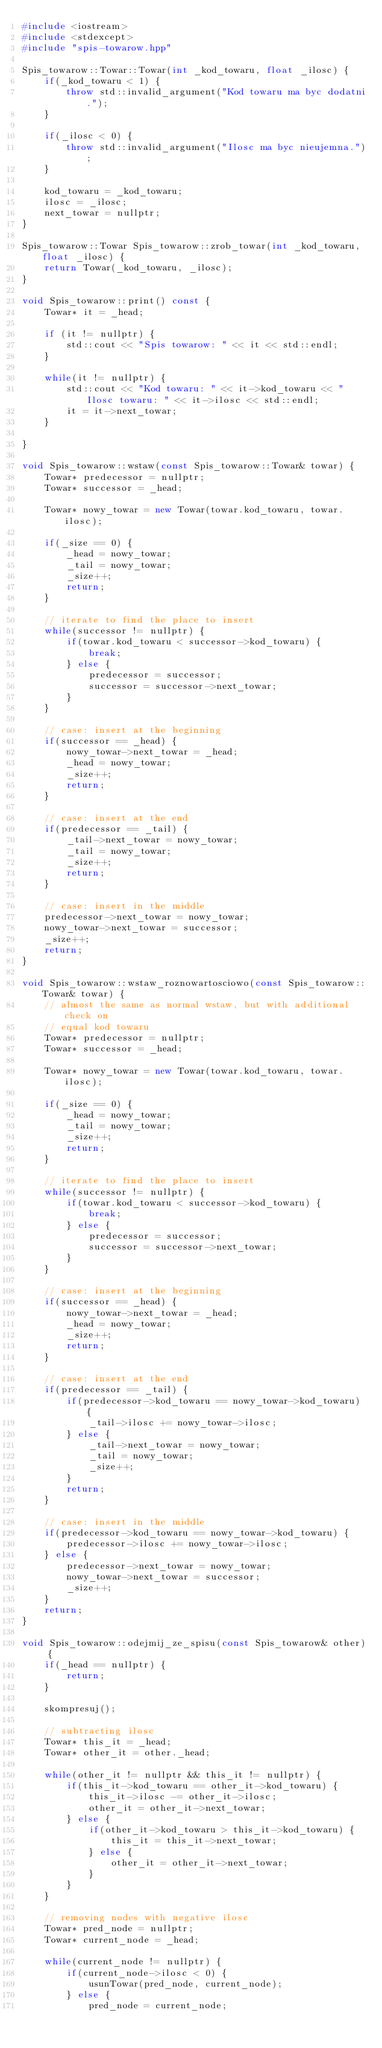<code> <loc_0><loc_0><loc_500><loc_500><_C++_>#include <iostream>
#include <stdexcept>
#include "spis-towarow.hpp"

Spis_towarow::Towar::Towar(int _kod_towaru, float _ilosc) {
    if(_kod_towaru < 1) {
        throw std::invalid_argument("Kod towaru ma byc dodatni.");
    }

    if(_ilosc < 0) {
        throw std::invalid_argument("Ilosc ma byc nieujemna.");
    }

    kod_towaru = _kod_towaru;
    ilosc = _ilosc;
    next_towar = nullptr;
}

Spis_towarow::Towar Spis_towarow::zrob_towar(int _kod_towaru, float _ilosc) {
    return Towar(_kod_towaru, _ilosc);
}

void Spis_towarow::print() const {
    Towar* it = _head;

    if (it != nullptr) {
        std::cout << "Spis towarow: " << it << std::endl;
    }

    while(it != nullptr) {
        std::cout << "Kod towaru: " << it->kod_towaru << " Ilosc towaru: " << it->ilosc << std::endl;
        it = it->next_towar;
    }
    
}

void Spis_towarow::wstaw(const Spis_towarow::Towar& towar) {
    Towar* predecessor = nullptr;
    Towar* successor = _head;

    Towar* nowy_towar = new Towar(towar.kod_towaru, towar.ilosc);

    if(_size == 0) {
        _head = nowy_towar;
        _tail = nowy_towar;
        _size++;
        return;
    }

    // iterate to find the place to insert
    while(successor != nullptr) {
        if(towar.kod_towaru < successor->kod_towaru) {
            break;
        } else {
            predecessor = successor;
            successor = successor->next_towar;
        }
    }

    // case: insert at the beginning
    if(successor == _head) {
        nowy_towar->next_towar = _head;
        _head = nowy_towar;
        _size++;
        return;
    }

    // case: insert at the end
    if(predecessor == _tail) {
        _tail->next_towar = nowy_towar;
        _tail = nowy_towar;
        _size++;
        return;
    }

    // case: insert in the middle
    predecessor->next_towar = nowy_towar;
    nowy_towar->next_towar = successor;
    _size++;
    return;
}

void Spis_towarow::wstaw_roznowartosciowo(const Spis_towarow::Towar& towar) {
    // almost the same as normal wstaw, but with additional check on
    // equal kod towaru
    Towar* predecessor = nullptr;
    Towar* successor = _head;

    Towar* nowy_towar = new Towar(towar.kod_towaru, towar.ilosc);

    if(_size == 0) {
        _head = nowy_towar;
        _tail = nowy_towar;
        _size++;
        return;
    }

    // iterate to find the place to insert
    while(successor != nullptr) {
        if(towar.kod_towaru < successor->kod_towaru) {
            break;
        } else {
            predecessor = successor;
            successor = successor->next_towar;
        }
    }

    // case: insert at the beginning
    if(successor == _head) {
        nowy_towar->next_towar = _head;
        _head = nowy_towar;
        _size++;
        return;
    }

    // case: insert at the end
    if(predecessor == _tail) {
        if(predecessor->kod_towaru == nowy_towar->kod_towaru) {
            _tail->ilosc += nowy_towar->ilosc;
        } else {
            _tail->next_towar = nowy_towar;
            _tail = nowy_towar;
            _size++;
        }
        return;
    }

    // case: insert in the middle
    if(predecessor->kod_towaru == nowy_towar->kod_towaru) {
        predecessor->ilosc += nowy_towar->ilosc;
    } else {
        predecessor->next_towar = nowy_towar;
        nowy_towar->next_towar = successor;
        _size++;
    }
    return;    
}

void Spis_towarow::odejmij_ze_spisu(const Spis_towarow& other) {
    if(_head == nullptr) {
        return;
    }

    skompresuj();

    // subtracting ilosc
    Towar* this_it = _head;
    Towar* other_it = other._head;

    while(other_it != nullptr && this_it != nullptr) {
        if(this_it->kod_towaru == other_it->kod_towaru) {
            this_it->ilosc -= other_it->ilosc;
            other_it = other_it->next_towar;
        } else {
            if(other_it->kod_towaru > this_it->kod_towaru) {
                this_it = this_it->next_towar;
            } else {
                other_it = other_it->next_towar;
            }
        }
    }

    // removing nodes with negative ilosc
    Towar* pred_node = nullptr;
    Towar* current_node = _head;

    while(current_node != nullptr) {
        if(current_node->ilosc < 0) {
            usunTowar(pred_node, current_node);
        } else {
            pred_node = current_node;</code> 